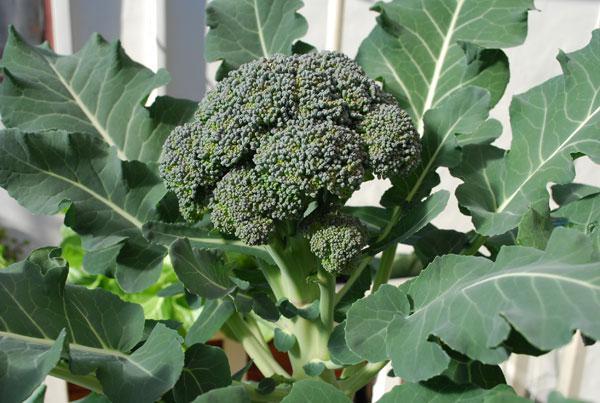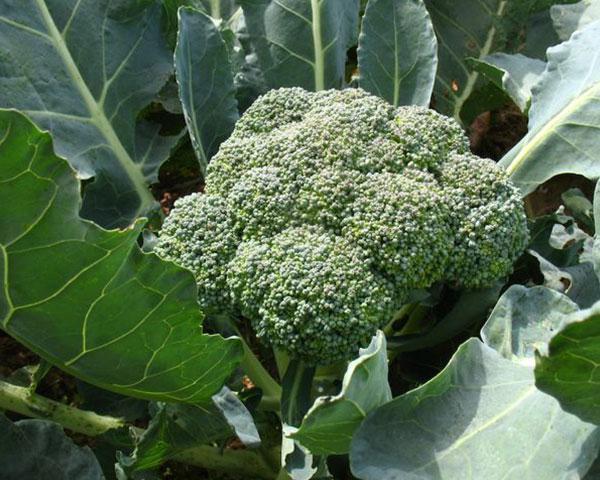The first image is the image on the left, the second image is the image on the right. For the images shown, is this caption "The left and right image contains the same number of head of broccoli." true? Answer yes or no. Yes. 